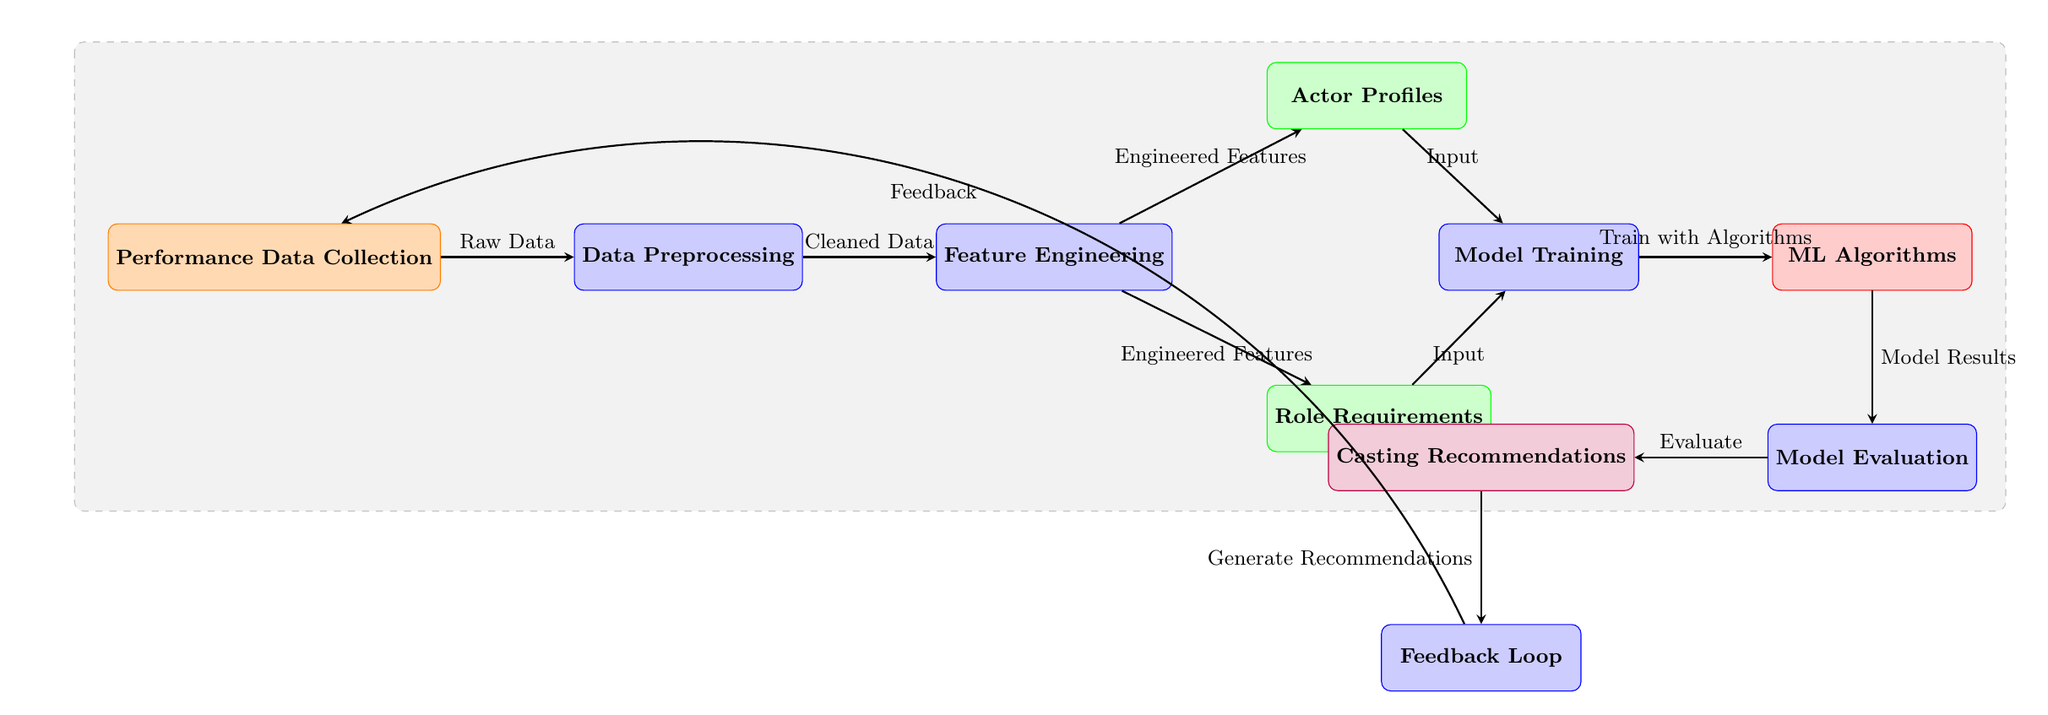What is the first step in the diagram? The first step, or initial node, in the diagram is labeled "Performance Data Collection," indicating the starting point of the data flow.
Answer: Performance Data Collection How many process nodes are present in the diagram? The diagram contains four process nodes: "Data Preprocessing," "Feature Engineering," "Model Training," and "Model Evaluation." By counting these, we find there are four process nodes.
Answer: 4 What flows into the "Model Training" node? The "Model Training" node receives input from two sources: "Actor Profiles" and "Role Requirements." Both of these nodes provide the necessary data for model training.
Answer: Actor Profiles, Role Requirements What is the last output of the diagram? The last output of the diagram is labeled "Casting Recommendations," which is the final result generated after evaluating the model.
Answer: Casting Recommendations What is the purpose of the "Feedback Loop"? The "Feedback Loop" is designed for integrating feedback into the system, allowing performance data to be re-collected and improve future recommendations. It serves as a mechanism for continuous improvement.
Answer: Improve recommendations How does the "Model Evaluation" connect to the next stage in the flow? The "Model Evaluation" node connects directly to the "Casting Recommendations" node, indicating that after evaluation, the recommendations are generated based on the model's performance assessment.
Answer: Casting Recommendations What kind of data is produced after "Data Preprocessing"? After "Data Preprocessing," the output is labeled "Cleaned Data," reflecting that the data has been cleaned and is ready for the next process.
Answer: Cleaned Data What algorithms are utilized in the training phase? The "Model Training" phase uses "ML Algorithms," which are specific algorithms applied to train the model using the data from actor profiles and role requirements.
Answer: ML Algorithms Which two data sources provide input for the "Feature Engineering" process? The data sources that provide input to the "Feature Engineering" process are "Actor Profiles" and "Role Requirements," both of which inform the engineering of features during this stage.
Answer: Actor Profiles, Role Requirements 